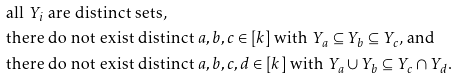<formula> <loc_0><loc_0><loc_500><loc_500>& \text {all $Y_{i}$ are distinct sets,} \\ & \text {there do not exist distinct $a,b,c\in[k]$ with $Y_{a}\subseteq Y_{b}\subseteq Y_{c}$, and} \\ & \text {there do not exist distinct $a,b,c,d\in[k]$ with $Y_{a}\cup Y_{b}\subseteq Y_{c}\cap Y_{d}$.}</formula> 